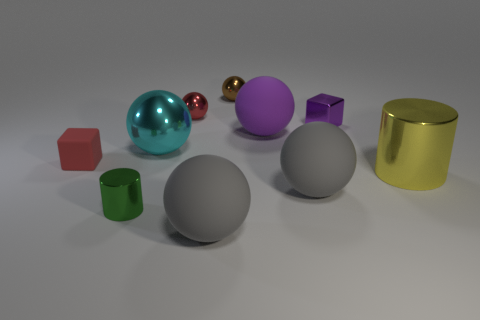Subtract all brown spheres. How many spheres are left? 5 Subtract all big shiny balls. How many balls are left? 5 Subtract all cubes. How many objects are left? 8 Add 1 cyan objects. How many cyan objects exist? 2 Subtract 0 blue cubes. How many objects are left? 10 Subtract 4 spheres. How many spheres are left? 2 Subtract all brown cylinders. Subtract all red balls. How many cylinders are left? 2 Subtract all purple spheres. How many yellow cylinders are left? 1 Subtract all small green objects. Subtract all tiny purple metallic objects. How many objects are left? 8 Add 2 red matte things. How many red matte things are left? 3 